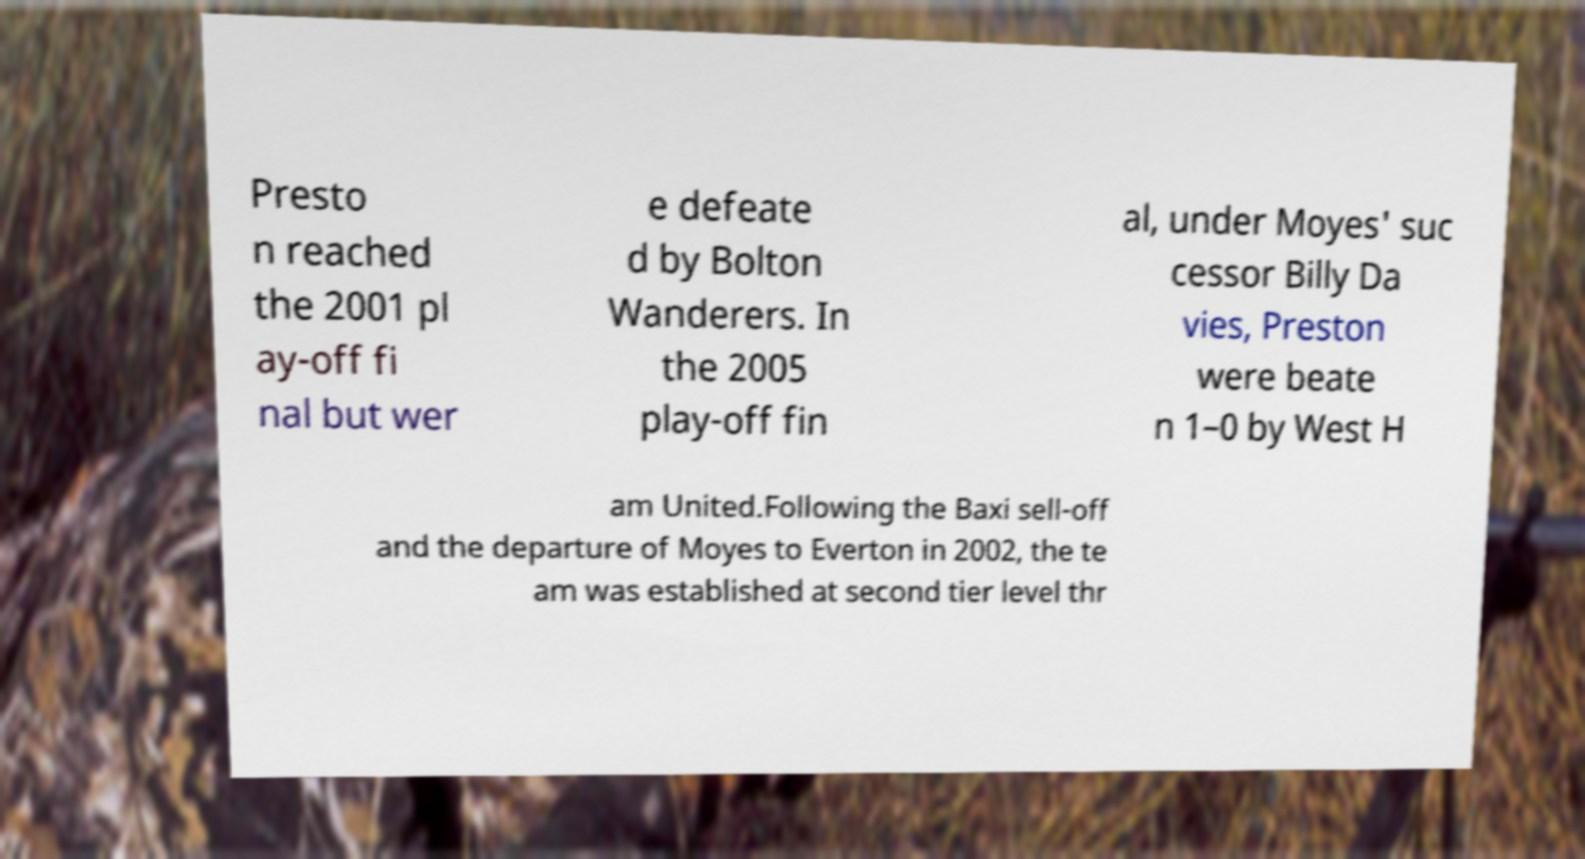Please identify and transcribe the text found in this image. Presto n reached the 2001 pl ay-off fi nal but wer e defeate d by Bolton Wanderers. In the 2005 play-off fin al, under Moyes' suc cessor Billy Da vies, Preston were beate n 1–0 by West H am United.Following the Baxi sell-off and the departure of Moyes to Everton in 2002, the te am was established at second tier level thr 